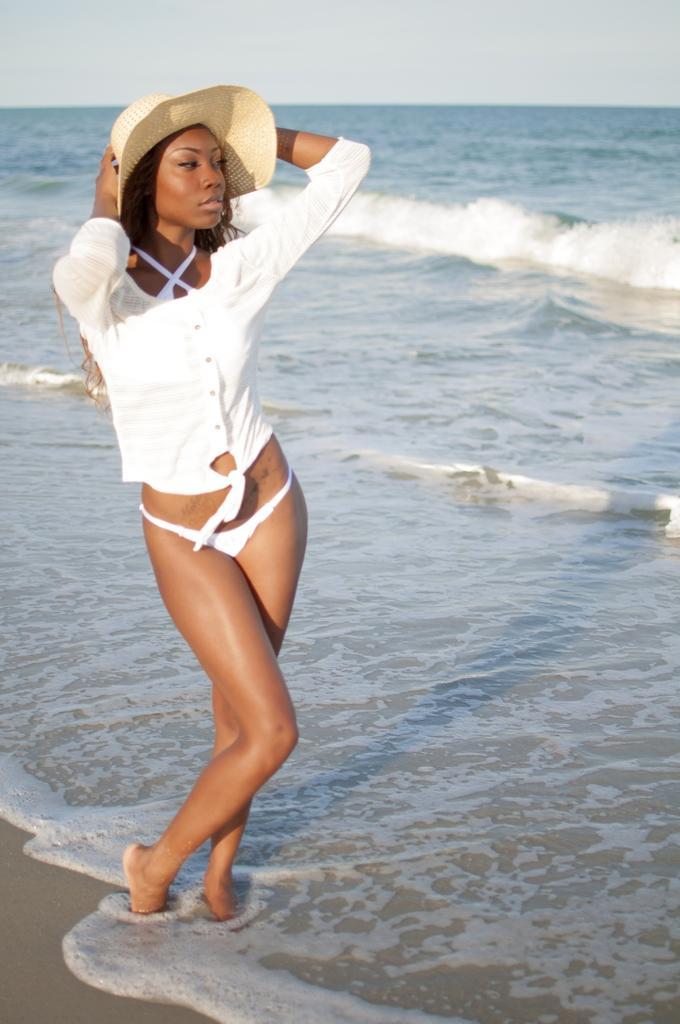Describe this image in one or two sentences. In this image, we can see a person on the beach. This person is wearing clothes and hat. There is a sky at the top of the image. 